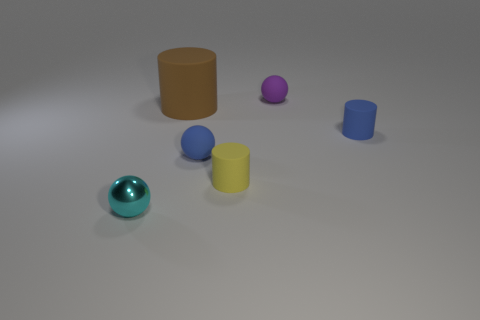Is there any other thing that is the same size as the brown rubber cylinder?
Make the answer very short. No. There is a object that is behind the big matte cylinder; is it the same shape as the cyan thing?
Offer a terse response. Yes. What is the material of the cyan thing?
Provide a short and direct response. Metal. The other yellow object that is the same size as the metallic object is what shape?
Your response must be concise. Cylinder. There is a matte cylinder that is left of the blue object that is on the left side of the yellow rubber cylinder; what color is it?
Offer a very short reply. Brown. Is there a small rubber object behind the tiny blue matte object that is left of the cylinder in front of the small blue ball?
Provide a short and direct response. Yes. There is a big cylinder that is the same material as the purple ball; what color is it?
Ensure brevity in your answer.  Brown. What number of cyan balls are made of the same material as the tiny purple sphere?
Offer a terse response. 0. Are the large object and the cylinder that is to the right of the tiny yellow rubber cylinder made of the same material?
Provide a succinct answer. Yes. How many objects are either small cylinders behind the tiny yellow object or cylinders?
Keep it short and to the point. 3. 